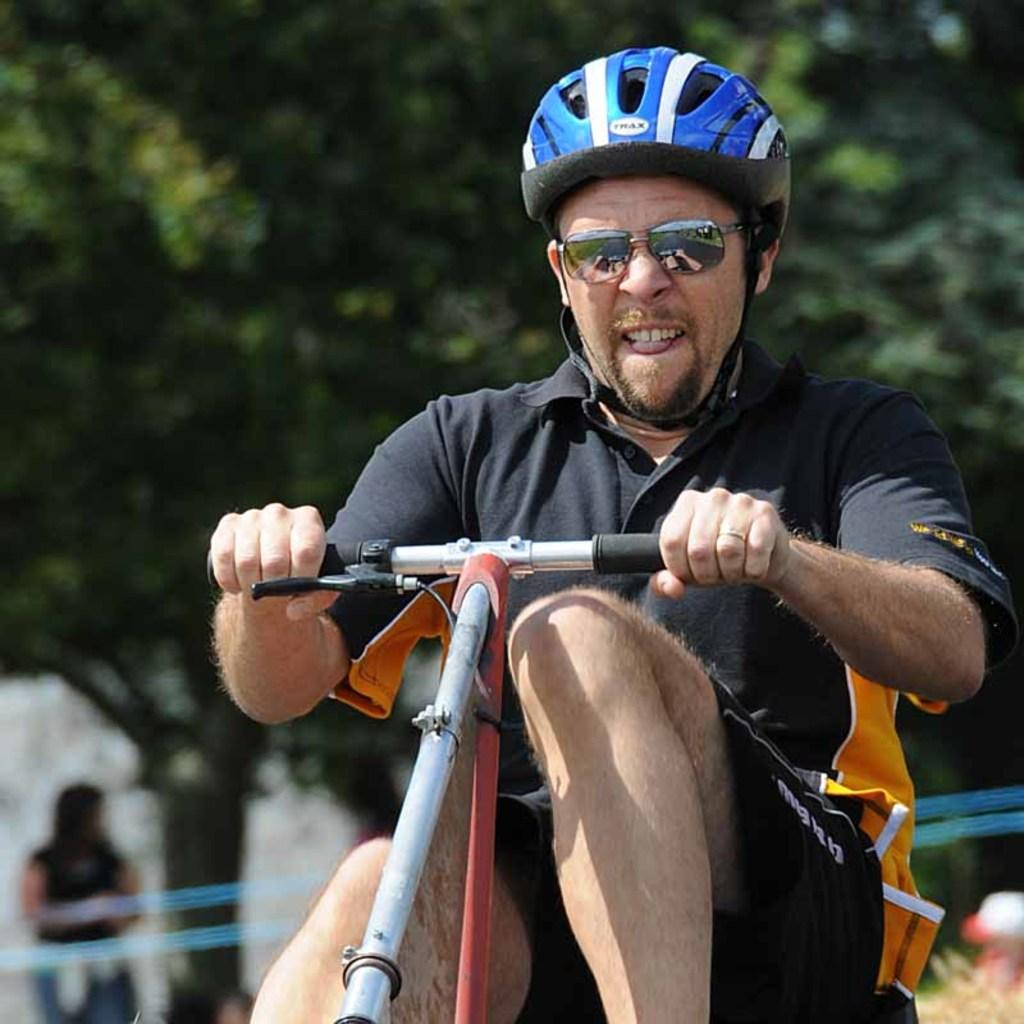What is the person in the image doing? The person is riding a bicycle. What is the person wearing on their head? The person is wearing a blue helmet. What color is the dress the person is wearing? The person is wearing a black dress. Can you describe the background of the image? There are trees visible in the background. Are there any other people in the image? Yes, there is another person visible in the background. What type of linen is being used to cover the hill in the image? There is no hill or linen present in the image. 